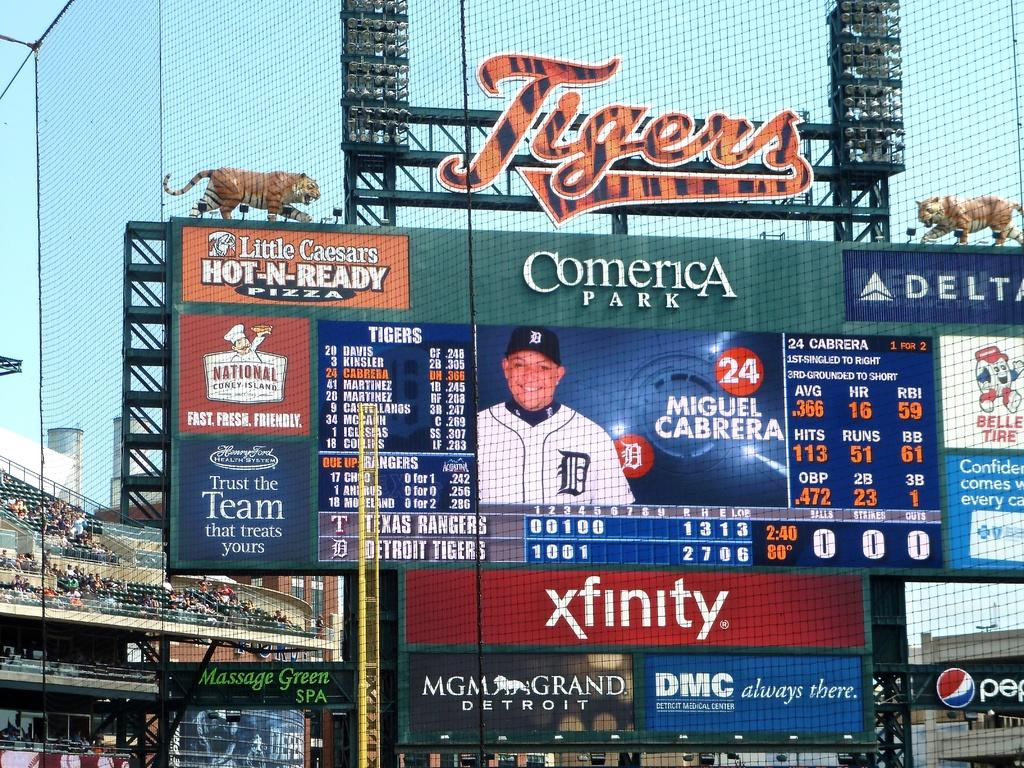<image>
Create a compact narrative representing the image presented. Tigers stadium big screen with a picture of miguel cabrera on the center. 